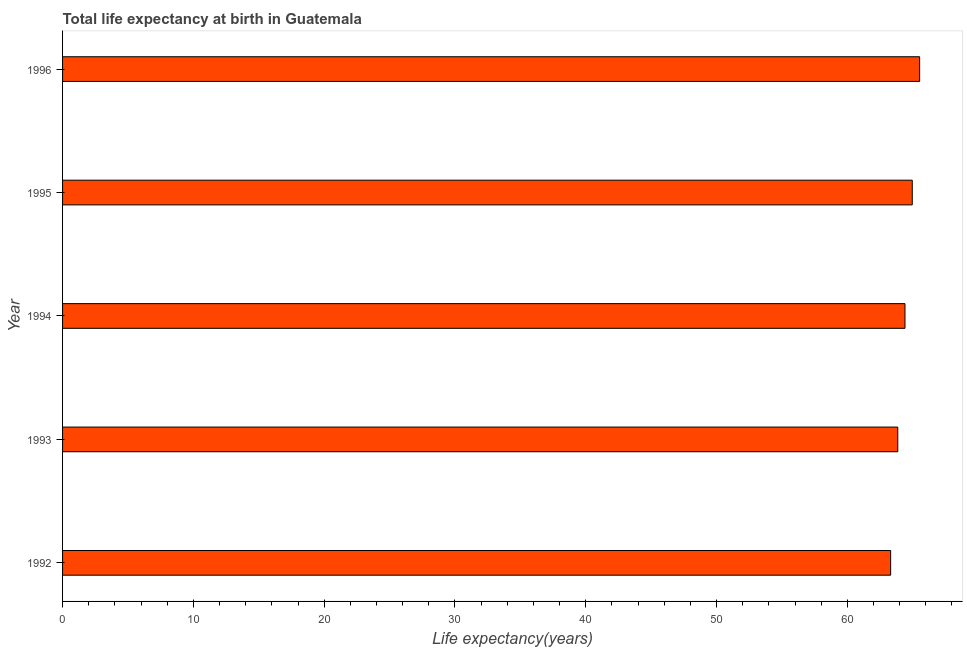Does the graph contain grids?
Keep it short and to the point. No. What is the title of the graph?
Provide a short and direct response. Total life expectancy at birth in Guatemala. What is the label or title of the X-axis?
Ensure brevity in your answer.  Life expectancy(years). What is the life expectancy at birth in 1993?
Keep it short and to the point. 63.86. Across all years, what is the maximum life expectancy at birth?
Provide a short and direct response. 65.53. Across all years, what is the minimum life expectancy at birth?
Make the answer very short. 63.31. What is the sum of the life expectancy at birth?
Offer a terse response. 322.06. What is the difference between the life expectancy at birth in 1992 and 1993?
Keep it short and to the point. -0.55. What is the average life expectancy at birth per year?
Offer a very short reply. 64.41. What is the median life expectancy at birth?
Your response must be concise. 64.41. In how many years, is the life expectancy at birth greater than 10 years?
Offer a very short reply. 5. Do a majority of the years between 1992 and 1996 (inclusive) have life expectancy at birth greater than 6 years?
Give a very brief answer. Yes. Is the life expectancy at birth in 1993 less than that in 1994?
Your answer should be compact. Yes. What is the difference between the highest and the second highest life expectancy at birth?
Your response must be concise. 0.56. Is the sum of the life expectancy at birth in 1995 and 1996 greater than the maximum life expectancy at birth across all years?
Make the answer very short. Yes. What is the difference between the highest and the lowest life expectancy at birth?
Offer a very short reply. 2.22. In how many years, is the life expectancy at birth greater than the average life expectancy at birth taken over all years?
Keep it short and to the point. 2. Are all the bars in the graph horizontal?
Provide a succinct answer. Yes. What is the Life expectancy(years) in 1992?
Provide a short and direct response. 63.31. What is the Life expectancy(years) of 1993?
Offer a terse response. 63.86. What is the Life expectancy(years) in 1994?
Keep it short and to the point. 64.41. What is the Life expectancy(years) of 1995?
Offer a very short reply. 64.96. What is the Life expectancy(years) of 1996?
Keep it short and to the point. 65.53. What is the difference between the Life expectancy(years) in 1992 and 1993?
Ensure brevity in your answer.  -0.54. What is the difference between the Life expectancy(years) in 1992 and 1994?
Your answer should be very brief. -1.09. What is the difference between the Life expectancy(years) in 1992 and 1995?
Make the answer very short. -1.65. What is the difference between the Life expectancy(years) in 1992 and 1996?
Your answer should be very brief. -2.22. What is the difference between the Life expectancy(years) in 1993 and 1994?
Your answer should be compact. -0.55. What is the difference between the Life expectancy(years) in 1993 and 1995?
Give a very brief answer. -1.11. What is the difference between the Life expectancy(years) in 1993 and 1996?
Provide a short and direct response. -1.67. What is the difference between the Life expectancy(years) in 1994 and 1995?
Offer a terse response. -0.56. What is the difference between the Life expectancy(years) in 1994 and 1996?
Your answer should be compact. -1.12. What is the difference between the Life expectancy(years) in 1995 and 1996?
Your answer should be very brief. -0.56. What is the ratio of the Life expectancy(years) in 1992 to that in 1994?
Keep it short and to the point. 0.98. What is the ratio of the Life expectancy(years) in 1992 to that in 1995?
Keep it short and to the point. 0.97. What is the ratio of the Life expectancy(years) in 1993 to that in 1996?
Your answer should be compact. 0.97. What is the ratio of the Life expectancy(years) in 1994 to that in 1995?
Make the answer very short. 0.99. 